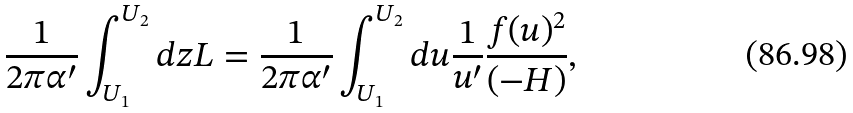Convert formula to latex. <formula><loc_0><loc_0><loc_500><loc_500>\frac { 1 } { 2 \pi \alpha ^ { \prime } } \int _ { U _ { 1 } } ^ { U _ { 2 } } d z L = \frac { 1 } { 2 \pi \alpha ^ { \prime } } \int _ { U _ { 1 } } ^ { U _ { 2 } } d u \frac { 1 } { u ^ { \prime } } \frac { f ( u ) ^ { 2 } } { ( - H ) } ,</formula> 